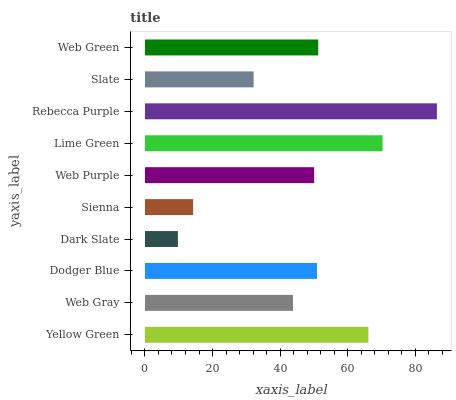Is Dark Slate the minimum?
Answer yes or no. Yes. Is Rebecca Purple the maximum?
Answer yes or no. Yes. Is Web Gray the minimum?
Answer yes or no. No. Is Web Gray the maximum?
Answer yes or no. No. Is Yellow Green greater than Web Gray?
Answer yes or no. Yes. Is Web Gray less than Yellow Green?
Answer yes or no. Yes. Is Web Gray greater than Yellow Green?
Answer yes or no. No. Is Yellow Green less than Web Gray?
Answer yes or no. No. Is Dodger Blue the high median?
Answer yes or no. Yes. Is Web Purple the low median?
Answer yes or no. Yes. Is Lime Green the high median?
Answer yes or no. No. Is Dodger Blue the low median?
Answer yes or no. No. 